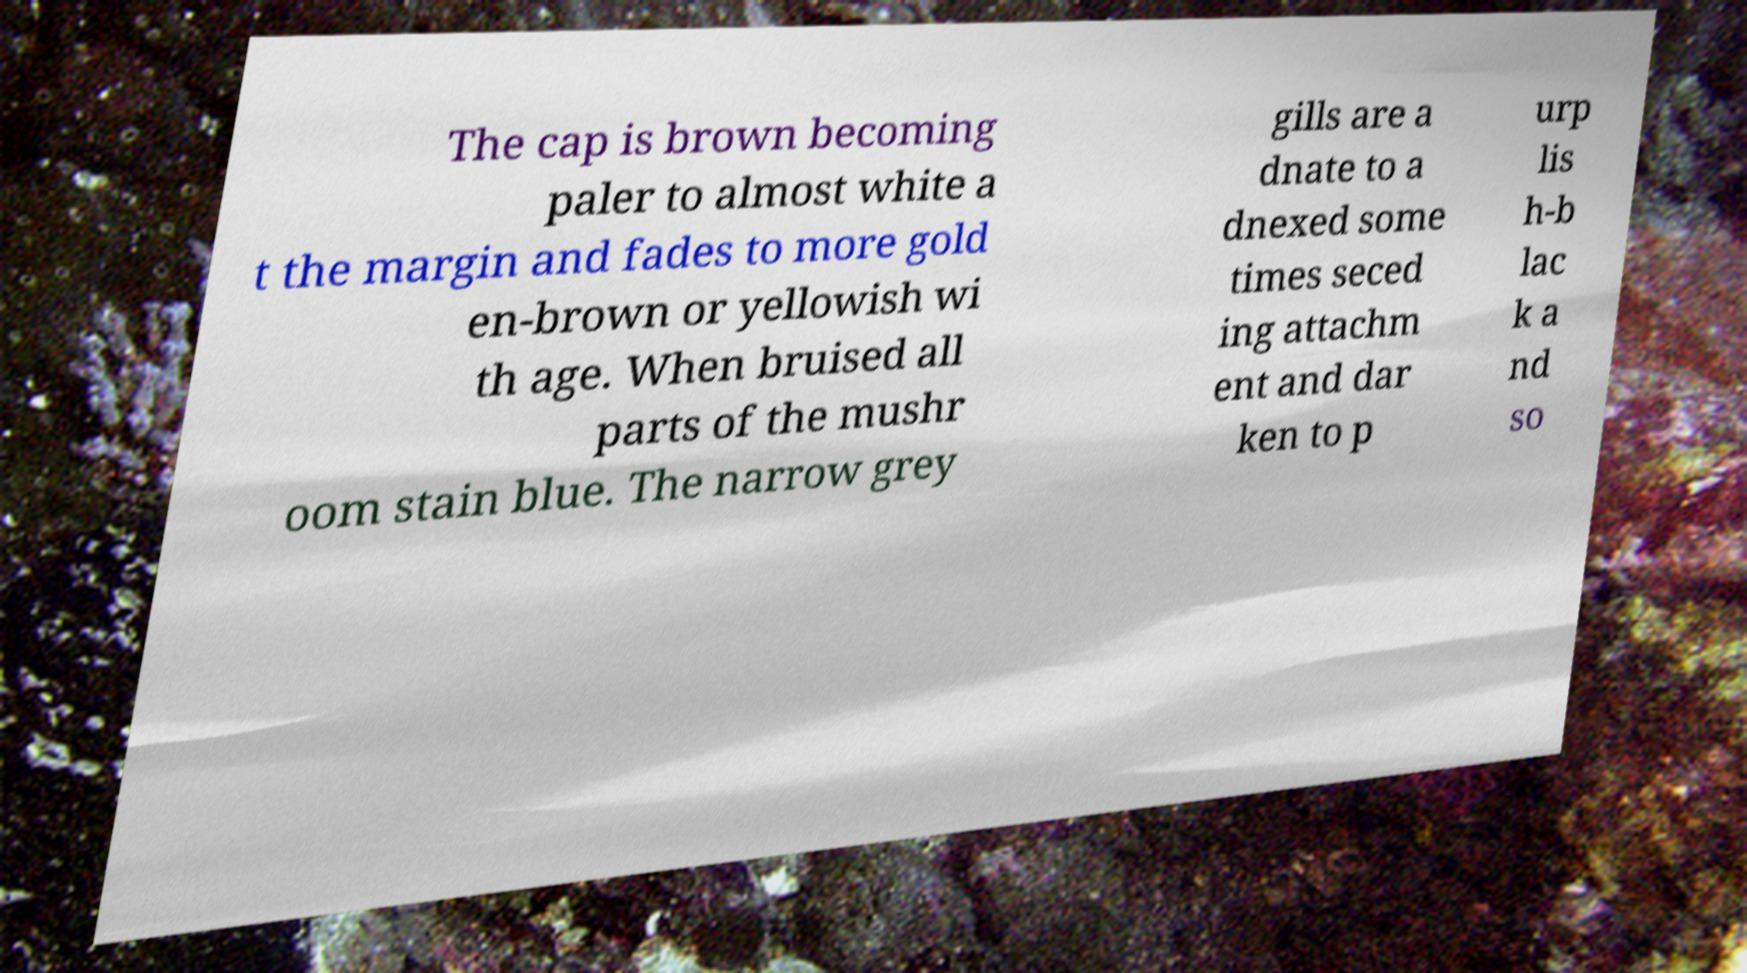Please identify and transcribe the text found in this image. The cap is brown becoming paler to almost white a t the margin and fades to more gold en-brown or yellowish wi th age. When bruised all parts of the mushr oom stain blue. The narrow grey gills are a dnate to a dnexed some times seced ing attachm ent and dar ken to p urp lis h-b lac k a nd so 